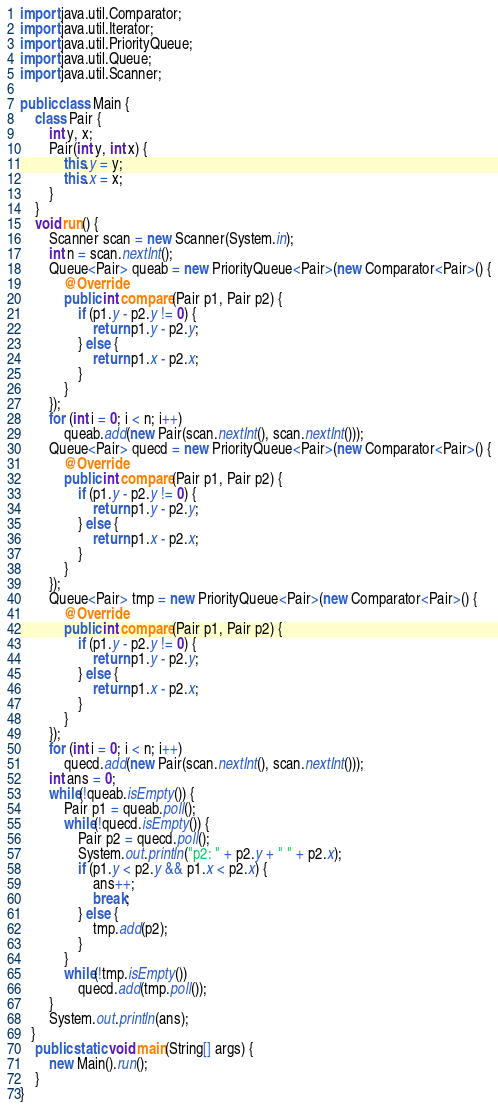<code> <loc_0><loc_0><loc_500><loc_500><_Java_>import java.util.Comparator;
import java.util.Iterator;
import java.util.PriorityQueue;
import java.util.Queue;
import java.util.Scanner;

public class Main {
    class Pair {
        int y, x;
        Pair(int y, int x) {
            this.y = y;
            this.x = x;
        }
    }
    void run() {
        Scanner scan = new Scanner(System.in);
        int n = scan.nextInt();
        Queue<Pair> queab = new PriorityQueue<Pair>(new Comparator<Pair>() {
            @Override
            public int compare(Pair p1, Pair p2) {
                if (p1.y - p2.y != 0) {
                    return p1.y - p2.y;
                } else {
                    return p1.x - p2.x;
                }
            }
        });
        for (int i = 0; i < n; i++)
            queab.add(new Pair(scan.nextInt(), scan.nextInt()));
        Queue<Pair> quecd = new PriorityQueue<Pair>(new Comparator<Pair>() {
            @Override
            public int compare(Pair p1, Pair p2) {
                if (p1.y - p2.y != 0) {
                    return p1.y - p2.y;
                } else {
                    return p1.x - p2.x;
                }
            }
        });
        Queue<Pair> tmp = new PriorityQueue<Pair>(new Comparator<Pair>() {
            @Override
            public int compare(Pair p1, Pair p2) {
                if (p1.y - p2.y != 0) {
                    return p1.y - p2.y;
                } else {
                    return p1.x - p2.x;
                }
            }
        });
        for (int i = 0; i < n; i++)
            quecd.add(new Pair(scan.nextInt(), scan.nextInt()));
        int ans = 0;
        while(!queab.isEmpty()) {
            Pair p1 = queab.poll();
            while(!quecd.isEmpty()) {
                Pair p2 = quecd.poll(); 
                System.out.println("p2: " + p2.y + " " + p2.x);
                if (p1.y < p2.y && p1.x < p2.x) {
                    ans++;
                    break;
                } else {
                    tmp.add(p2);
                }
            }
            while(!tmp.isEmpty())
                quecd.add(tmp.poll());
        }
        System.out.println(ans);
   }
    public static void main(String[] args) {
        new Main().run();
    }
}
</code> 